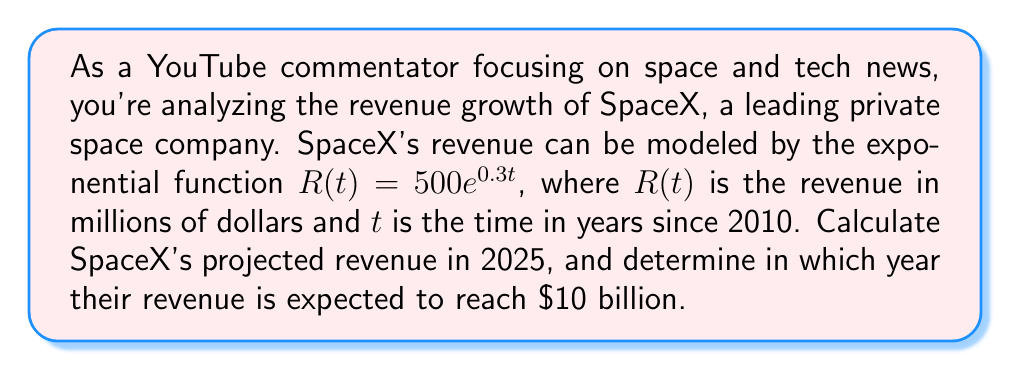Teach me how to tackle this problem. To solve this problem, we'll use the given exponential function and apply it to the specific years in question.

1. Calculating SpaceX's projected revenue in 2025:
   - 2025 is 15 years after 2010, so we'll use $t = 15$
   - $R(15) = 500e^{0.3(15)}$
   - $R(15) = 500e^{4.5}$
   - $R(15) = 500 \cdot 90.0171$ (using a calculator)
   - $R(15) \approx 45,008.55$ million dollars, or $45.01 billion

2. Determining the year when revenue reaches $10 billion:
   - We need to solve the equation: $500e^{0.3t} = 10,000$
   - Divide both sides by 500: $e^{0.3t} = 20$
   - Take the natural log of both sides: $\ln(e^{0.3t}) = \ln(20)$
   - Simplify: $0.3t = \ln(20)$
   - Divide both sides by 0.3: $t = \frac{\ln(20)}{0.3}$
   - $t \approx 10.0226$ years after 2010

   This corresponds to early 2020 (2010 + 10.0226 years).
Answer: SpaceX's projected revenue in 2025 is approximately $45.01 billion. Their revenue is expected to reach $10 billion in early 2020. 